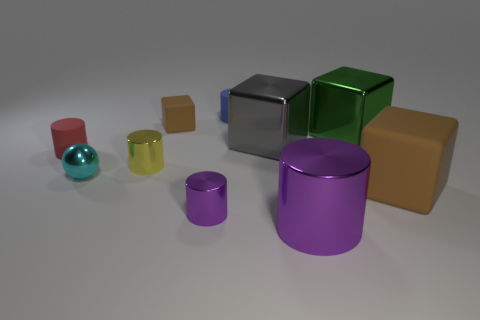Subtract 2 cylinders. How many cylinders are left? 3 Subtract all tiny purple metal cylinders. How many cylinders are left? 4 Subtract all blue cylinders. How many cylinders are left? 4 Subtract all green cylinders. Subtract all gray balls. How many cylinders are left? 5 Subtract all blocks. How many objects are left? 6 Add 5 tiny brown things. How many tiny brown things are left? 6 Add 6 big purple objects. How many big purple objects exist? 7 Subtract 0 purple balls. How many objects are left? 10 Subtract all big brown things. Subtract all small brown cubes. How many objects are left? 8 